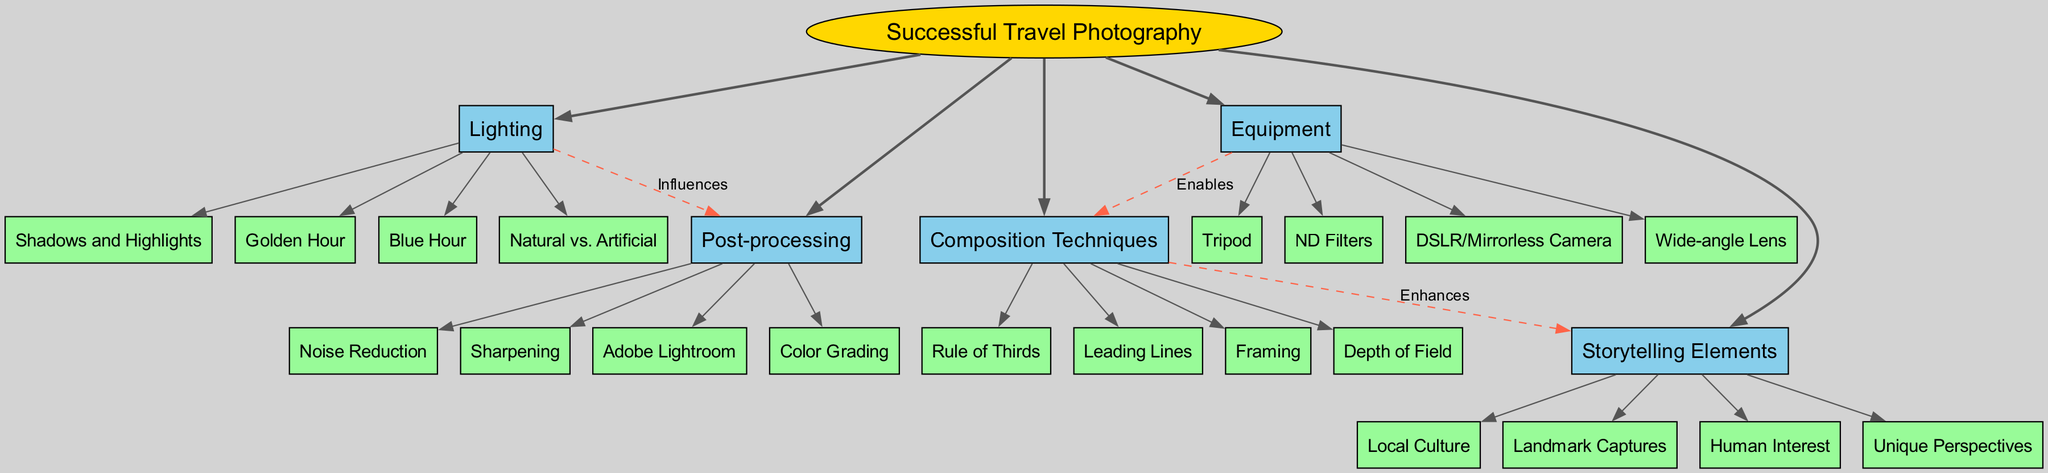What is the central topic of the diagram? The central topic node is explicitly labeled as "Successful Travel Photography." Therefore, the answer is simply the text from that node.
Answer: Successful Travel Photography How many main branches are there in the diagram? There are five main branches illustrated in the diagram: Composition Techniques, Lighting, Equipment, Post-processing, and Storytelling Elements. Counting these branches gives us the total of five.
Answer: 5 Which technique under Composition Techniques enhances Storytelling Elements? The diagram shows a dashed connection from Composition Techniques to Storytelling Elements labeled "Enhances." This indicates that one or more techniques from the Composition Techniques improve storytelling elements. The techniques listed under Composition Techniques include factors like the Rule of Thirds, which is commonly known to enhance such narratives.
Answer: Rule of Thirds What influences the post-processing according to the diagram? The diagram shows a connection labeled "Influences" from Lighting to Post-processing. Therefore, the role of lighting affects the overall post-processing techniques that a photographer may employ.
Answer: Lighting Which equipment enables the composition techniques? The diagram indicates a direct relationship where the Equipment branch connects to Composition Techniques labeled "Enables." The equipment listed includes a DSLR/Mirrorless Camera, which is vital for enabling a variety of composition techniques.
Answer: DSLR/Mirrorless Camera What is one of the sub-branches listed under Lighting? The Lighting branch contains several sub-branches, including Golden Hour, Blue Hour, Natural vs. Artificial, and Shadows and Highlights. Each of these aspects plays an important role in travel photography. Therefore, mentioning any of these specifically answers the question.
Answer: Golden Hour How does Equipment relate to Composition Techniques? The Equipment branch has a direct connection to Composition Techniques, denoted by the label "Enables." This means that having the right equipment is necessary for effectively applying composition techniques in travel photography.
Answer: Enables What is a sub-branch under Post-processing? Within the Post-processing branch, there are several techniques listed, including Adobe Lightroom, Color Grading, Noise Reduction, and Sharpening. Mentioning any of these will appropriately answer the question.
Answer: Adobe Lightroom What is the purpose of using ND Filters as listed in the Equipment branch? Although the diagram does not explicitly state the purposes of items under Equipment, ND Filters are generally known in photography for enabling longer exposure times and managing bright conditions. This is inferred from their position in the branch.
Answer: Managing brightness 